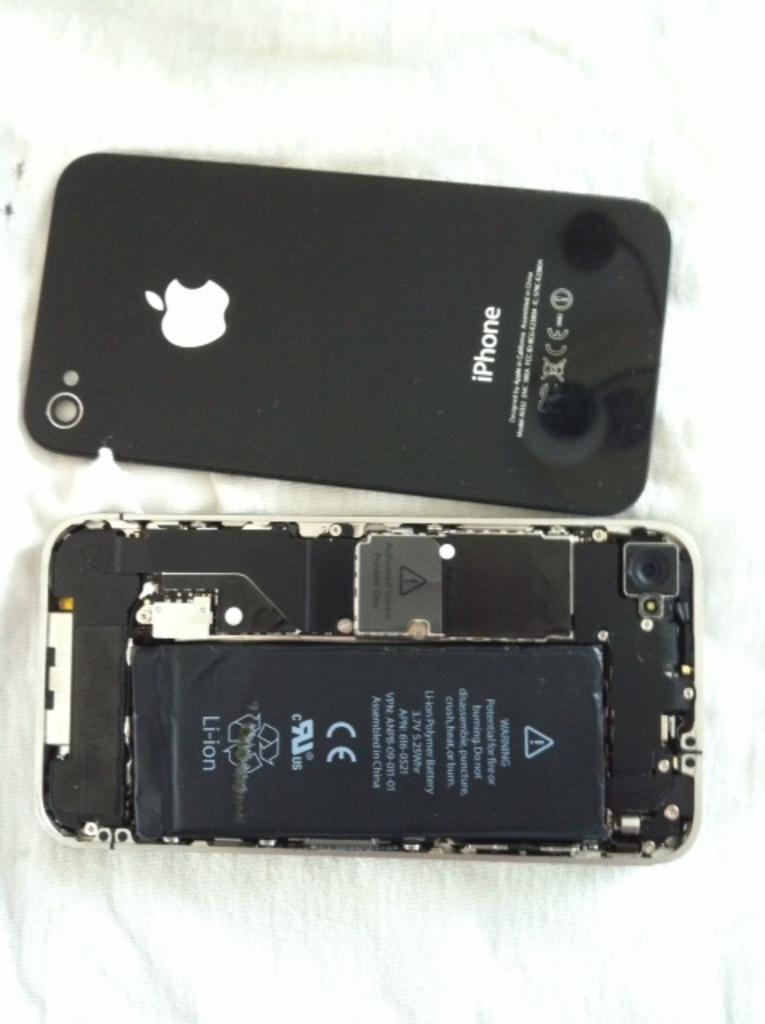<image>
Provide a brief description of the given image. The back of an iphone is laying down next to the iphone with the battery side up. 